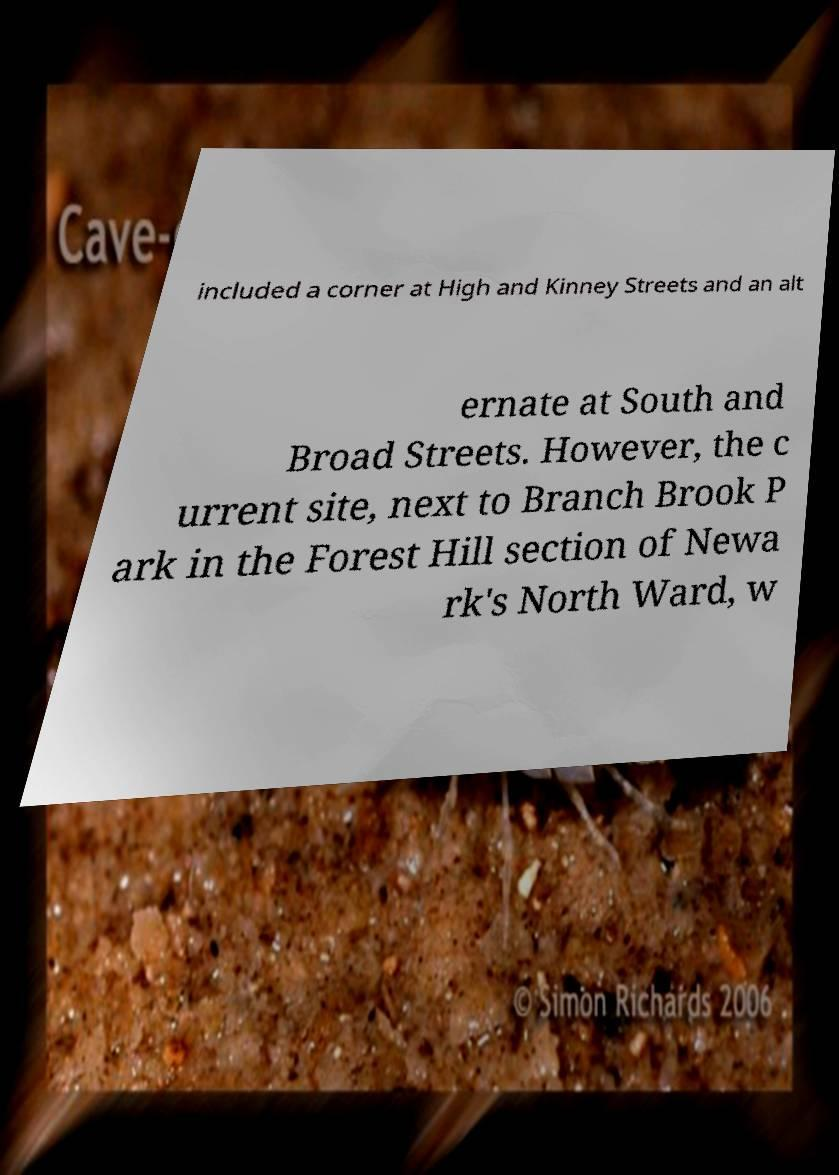There's text embedded in this image that I need extracted. Can you transcribe it verbatim? included a corner at High and Kinney Streets and an alt ernate at South and Broad Streets. However, the c urrent site, next to Branch Brook P ark in the Forest Hill section of Newa rk's North Ward, w 